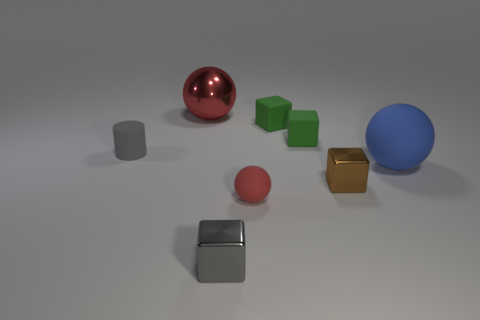What is the ball that is both behind the brown object and to the right of the big red ball made of?
Your answer should be very brief. Rubber. What number of brown blocks are in front of the large matte ball?
Offer a terse response. 1. There is a big thing that is the same material as the gray cylinder; what color is it?
Provide a short and direct response. Blue. Does the tiny red matte object have the same shape as the blue object?
Provide a succinct answer. Yes. What number of small things are both in front of the big blue sphere and on the right side of the small gray metallic thing?
Your answer should be very brief. 2. What number of metallic objects are either tiny red spheres or big cyan objects?
Offer a very short reply. 0. There is a ball to the left of the red thing in front of the brown block; what size is it?
Give a very brief answer. Large. There is a tiny object that is the same color as the big metal ball; what material is it?
Provide a short and direct response. Rubber. Are there any large things on the right side of the small rubber object that is in front of the matte ball that is to the right of the small red matte thing?
Offer a terse response. Yes. Do the sphere that is in front of the large blue thing and the large ball that is to the right of the brown block have the same material?
Offer a very short reply. Yes. 